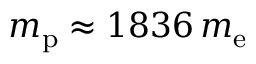<formula> <loc_0><loc_0><loc_500><loc_500>m _ { p } \approx 1 8 3 6 \, m _ { e }</formula> 